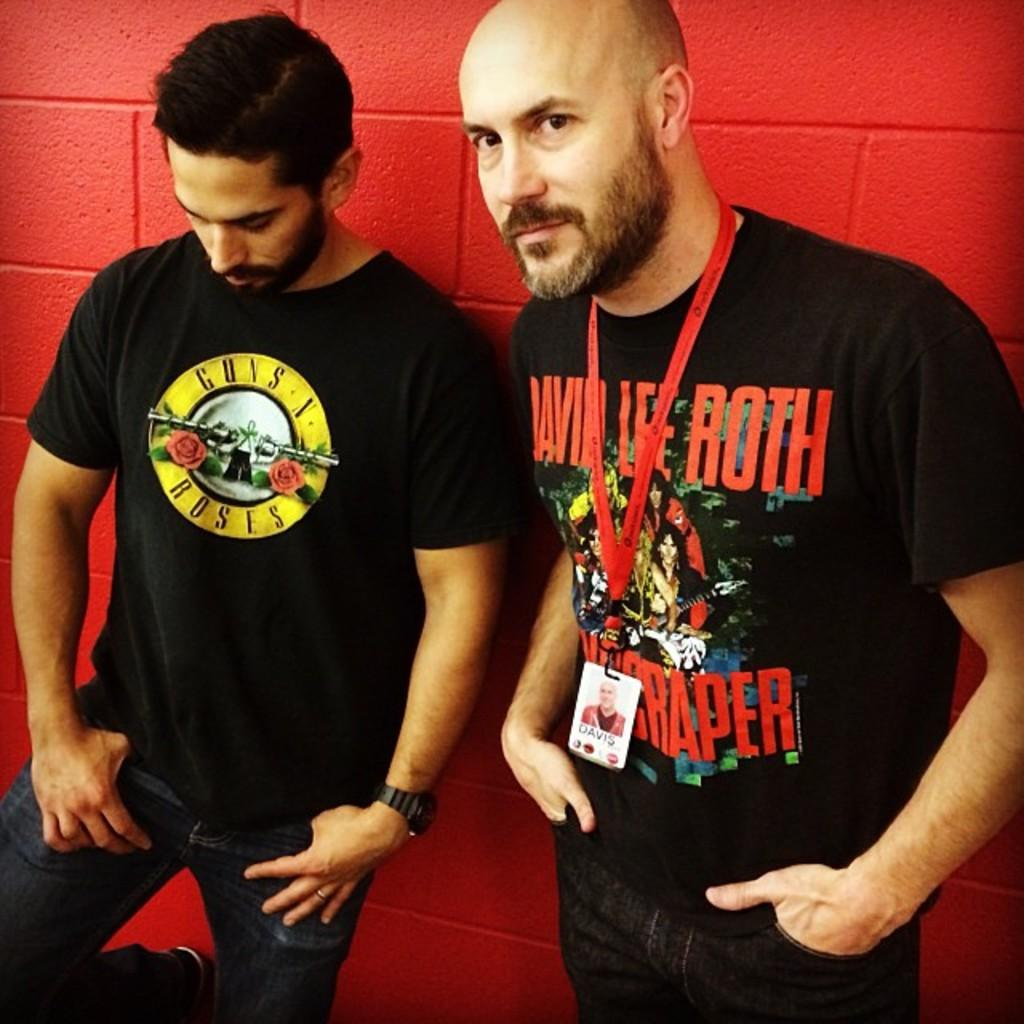<image>
Provide a brief description of the given image. A man is wearing a Guns N Roses shirt. 